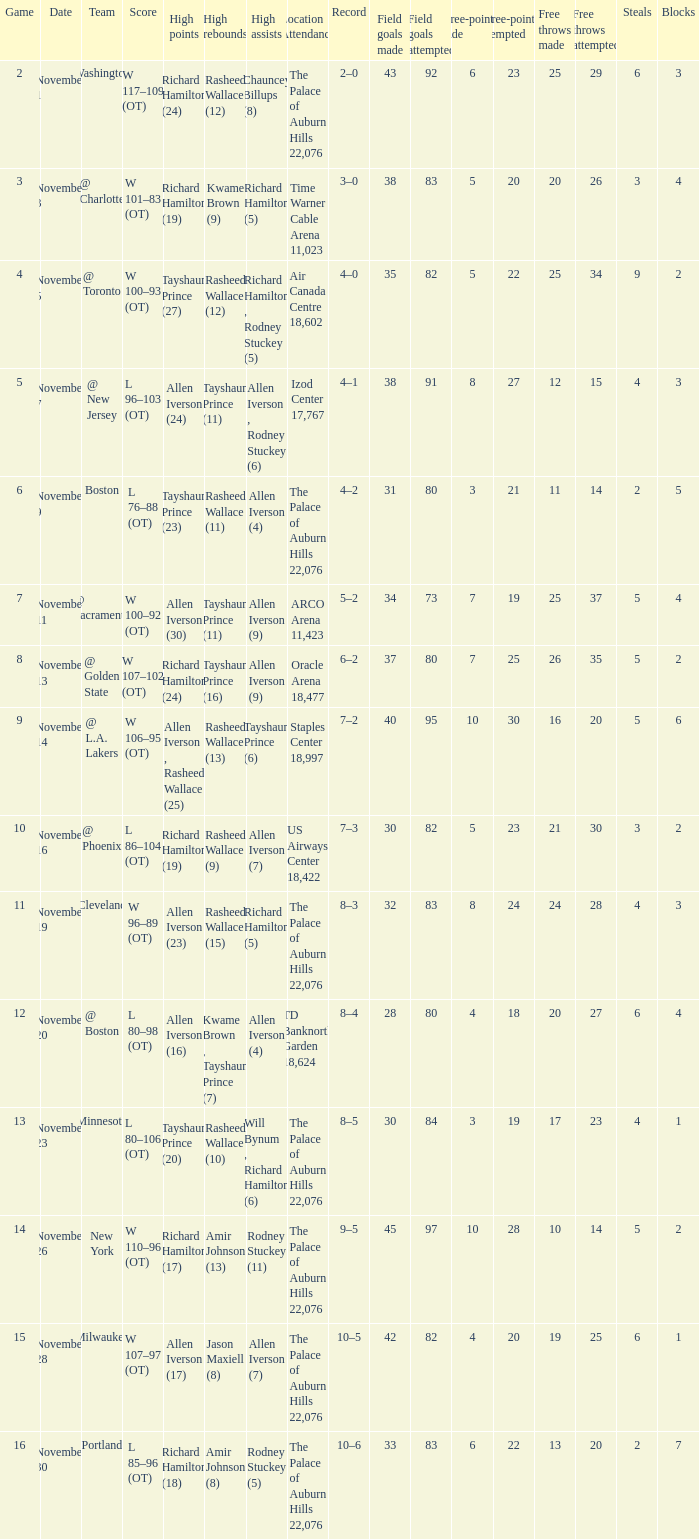What is the site attendance, when maximum points is "allen iverson (23)"? The Palace of Auburn Hills 22,076. 